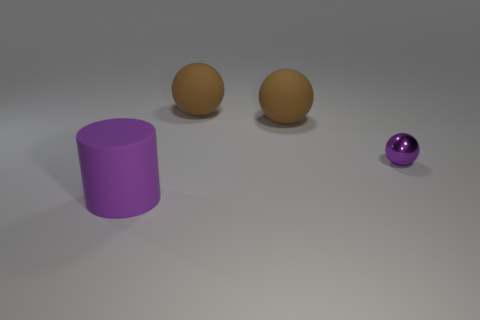Subtract all large balls. How many balls are left? 1 Subtract all green cubes. How many brown balls are left? 2 Add 1 big things. How many objects exist? 5 Subtract all purple spheres. How many spheres are left? 2 Subtract 1 spheres. How many spheres are left? 2 Subtract all balls. How many objects are left? 1 Add 4 spheres. How many spheres are left? 7 Add 3 small metallic objects. How many small metallic objects exist? 4 Subtract 0 cyan cylinders. How many objects are left? 4 Subtract all cyan spheres. Subtract all purple cylinders. How many spheres are left? 3 